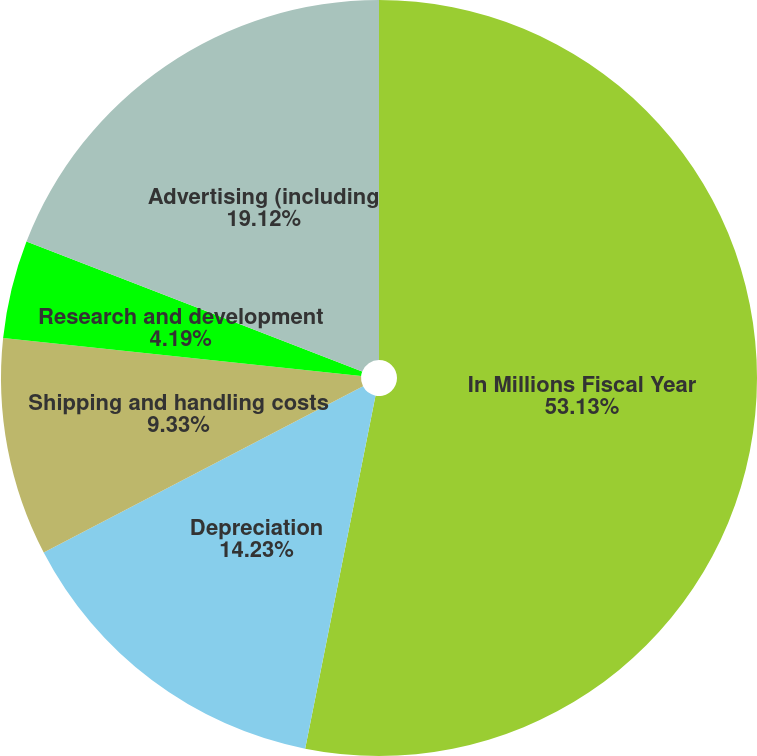Convert chart. <chart><loc_0><loc_0><loc_500><loc_500><pie_chart><fcel>In Millions Fiscal Year<fcel>Depreciation<fcel>Shipping and handling costs<fcel>Research and development<fcel>Advertising (including<nl><fcel>53.13%<fcel>14.23%<fcel>9.33%<fcel>4.19%<fcel>19.12%<nl></chart> 